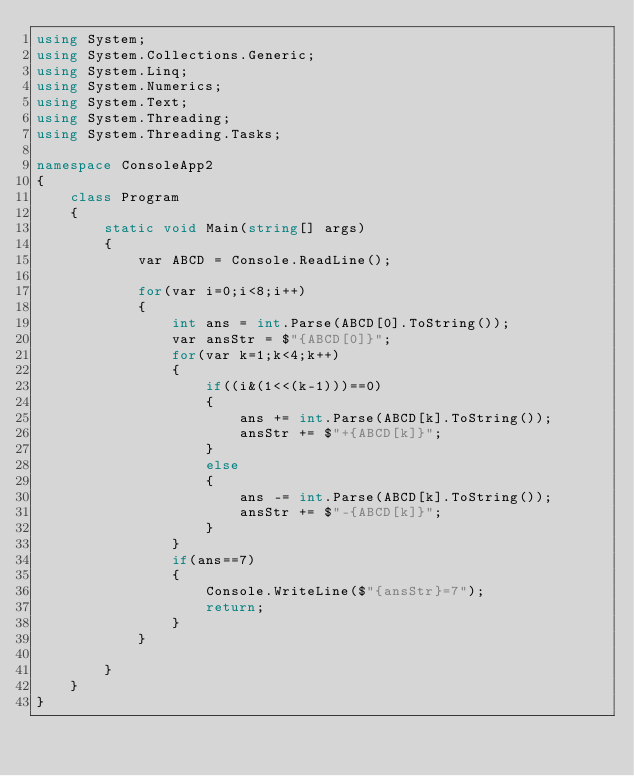<code> <loc_0><loc_0><loc_500><loc_500><_C#_>using System;
using System.Collections.Generic;
using System.Linq;
using System.Numerics;
using System.Text;
using System.Threading;
using System.Threading.Tasks;

namespace ConsoleApp2
{
    class Program
    {
        static void Main(string[] args)
        {
            var ABCD = Console.ReadLine();

            for(var i=0;i<8;i++)
            {
                int ans = int.Parse(ABCD[0].ToString());
                var ansStr = $"{ABCD[0]}";
                for(var k=1;k<4;k++)
                {
                    if((i&(1<<(k-1)))==0)
                    {
                        ans += int.Parse(ABCD[k].ToString());
                        ansStr += $"+{ABCD[k]}";
                    }
                    else
                    {
                        ans -= int.Parse(ABCD[k].ToString());
                        ansStr += $"-{ABCD[k]}";
                    }
                }
                if(ans==7)
                {
                    Console.WriteLine($"{ansStr}=7");
                    return;
                }
            }

        }
    }
}
</code> 